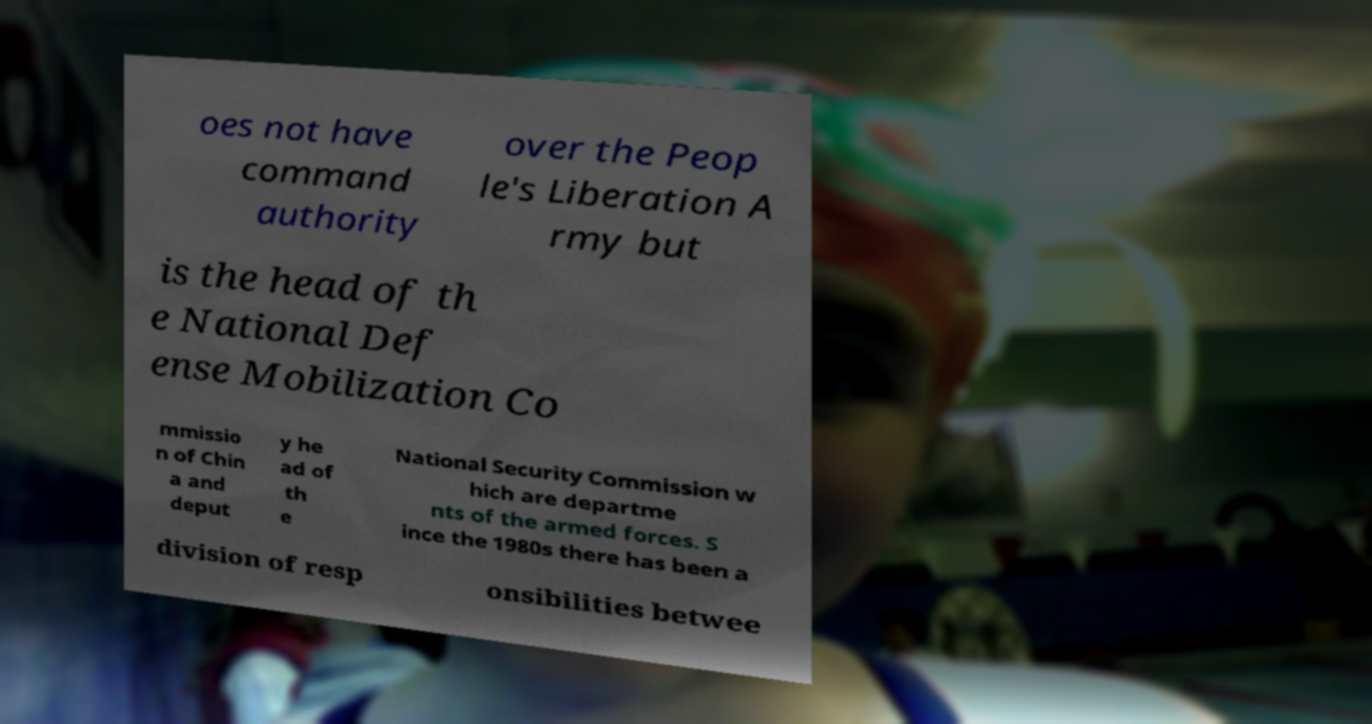Could you assist in decoding the text presented in this image and type it out clearly? oes not have command authority over the Peop le's Liberation A rmy but is the head of th e National Def ense Mobilization Co mmissio n of Chin a and deput y he ad of th e National Security Commission w hich are departme nts of the armed forces. S ince the 1980s there has been a division of resp onsibilities betwee 